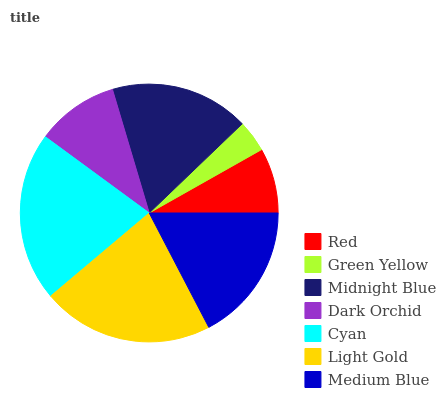Is Green Yellow the minimum?
Answer yes or no. Yes. Is Light Gold the maximum?
Answer yes or no. Yes. Is Midnight Blue the minimum?
Answer yes or no. No. Is Midnight Blue the maximum?
Answer yes or no. No. Is Midnight Blue greater than Green Yellow?
Answer yes or no. Yes. Is Green Yellow less than Midnight Blue?
Answer yes or no. Yes. Is Green Yellow greater than Midnight Blue?
Answer yes or no. No. Is Midnight Blue less than Green Yellow?
Answer yes or no. No. Is Medium Blue the high median?
Answer yes or no. Yes. Is Medium Blue the low median?
Answer yes or no. Yes. Is Midnight Blue the high median?
Answer yes or no. No. Is Light Gold the low median?
Answer yes or no. No. 